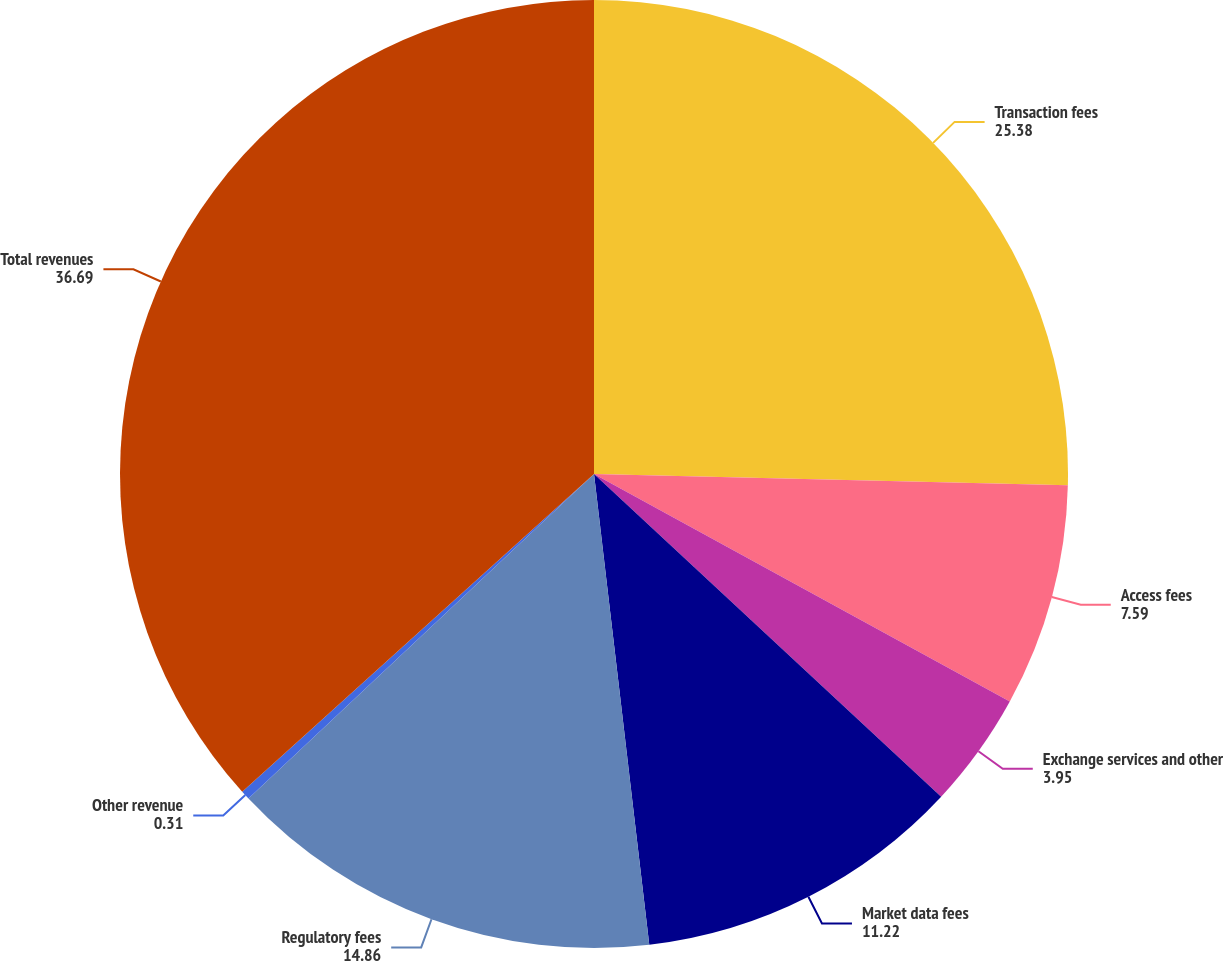<chart> <loc_0><loc_0><loc_500><loc_500><pie_chart><fcel>Transaction fees<fcel>Access fees<fcel>Exchange services and other<fcel>Market data fees<fcel>Regulatory fees<fcel>Other revenue<fcel>Total revenues<nl><fcel>25.38%<fcel>7.59%<fcel>3.95%<fcel>11.22%<fcel>14.86%<fcel>0.31%<fcel>36.69%<nl></chart> 